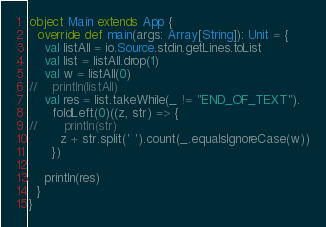<code> <loc_0><loc_0><loc_500><loc_500><_Scala_>object Main extends App {
  override def main(args: Array[String]): Unit = {
    val listAll = io.Source.stdin.getLines.toList
    val list = listAll.drop(1)
    val w = listAll(0)
//    println(listAll)
    val res = list.takeWhile(_ != "END_OF_TEXT").
      foldLeft(0)((z, str) => {
//       println(str)
        z + str.split(' ').count(_.equalsIgnoreCase(w))
      })

    println(res)
  }
}</code> 